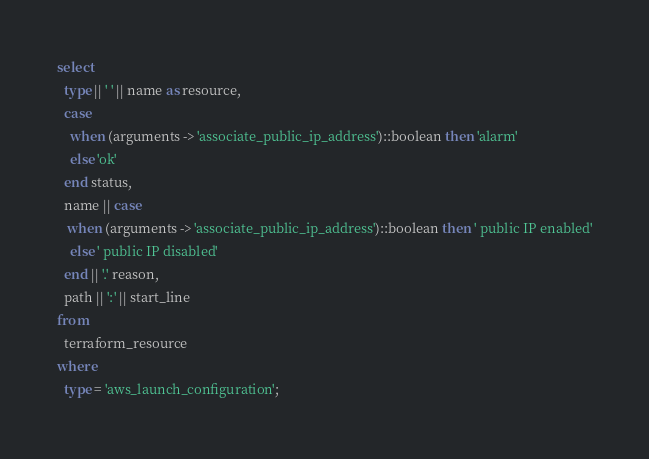Convert code to text. <code><loc_0><loc_0><loc_500><loc_500><_SQL_>select
  type || ' ' || name as resource,
  case
    when (arguments -> 'associate_public_ip_address')::boolean then 'alarm'
    else 'ok'
  end status,
  name || case
   when (arguments -> 'associate_public_ip_address')::boolean then ' public IP enabled'
    else ' public IP disabled'
  end || '.' reason,
  path || ':' || start_line
from
  terraform_resource
where
  type = 'aws_launch_configuration';</code> 